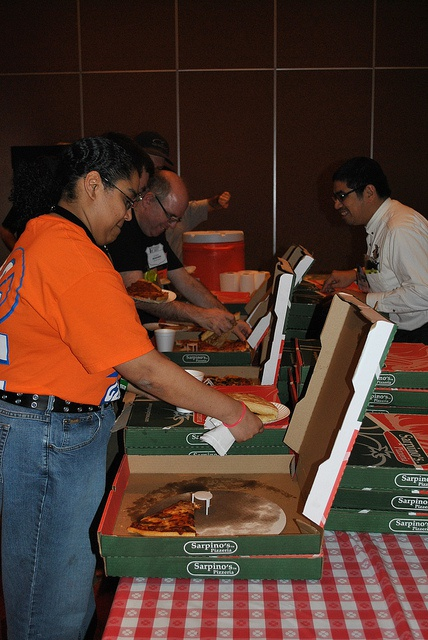Describe the objects in this image and their specific colors. I can see dining table in black, maroon, brown, and darkgreen tones, people in black, red, blue, and darkblue tones, people in black, gray, and maroon tones, people in black, maroon, brown, and gray tones, and people in black, maroon, and brown tones in this image. 